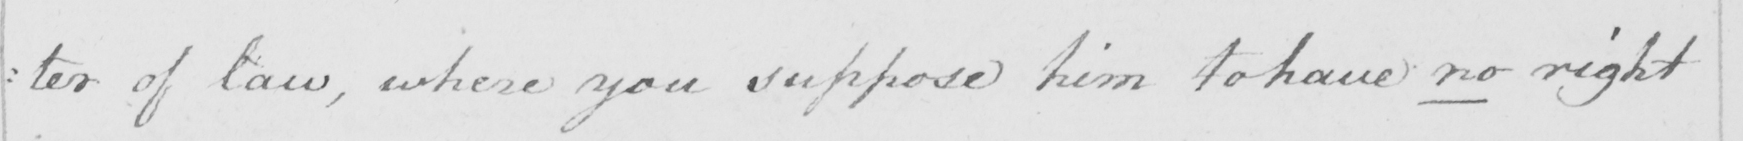Can you tell me what this handwritten text says? :ter of law, where you suppose him to have no right 